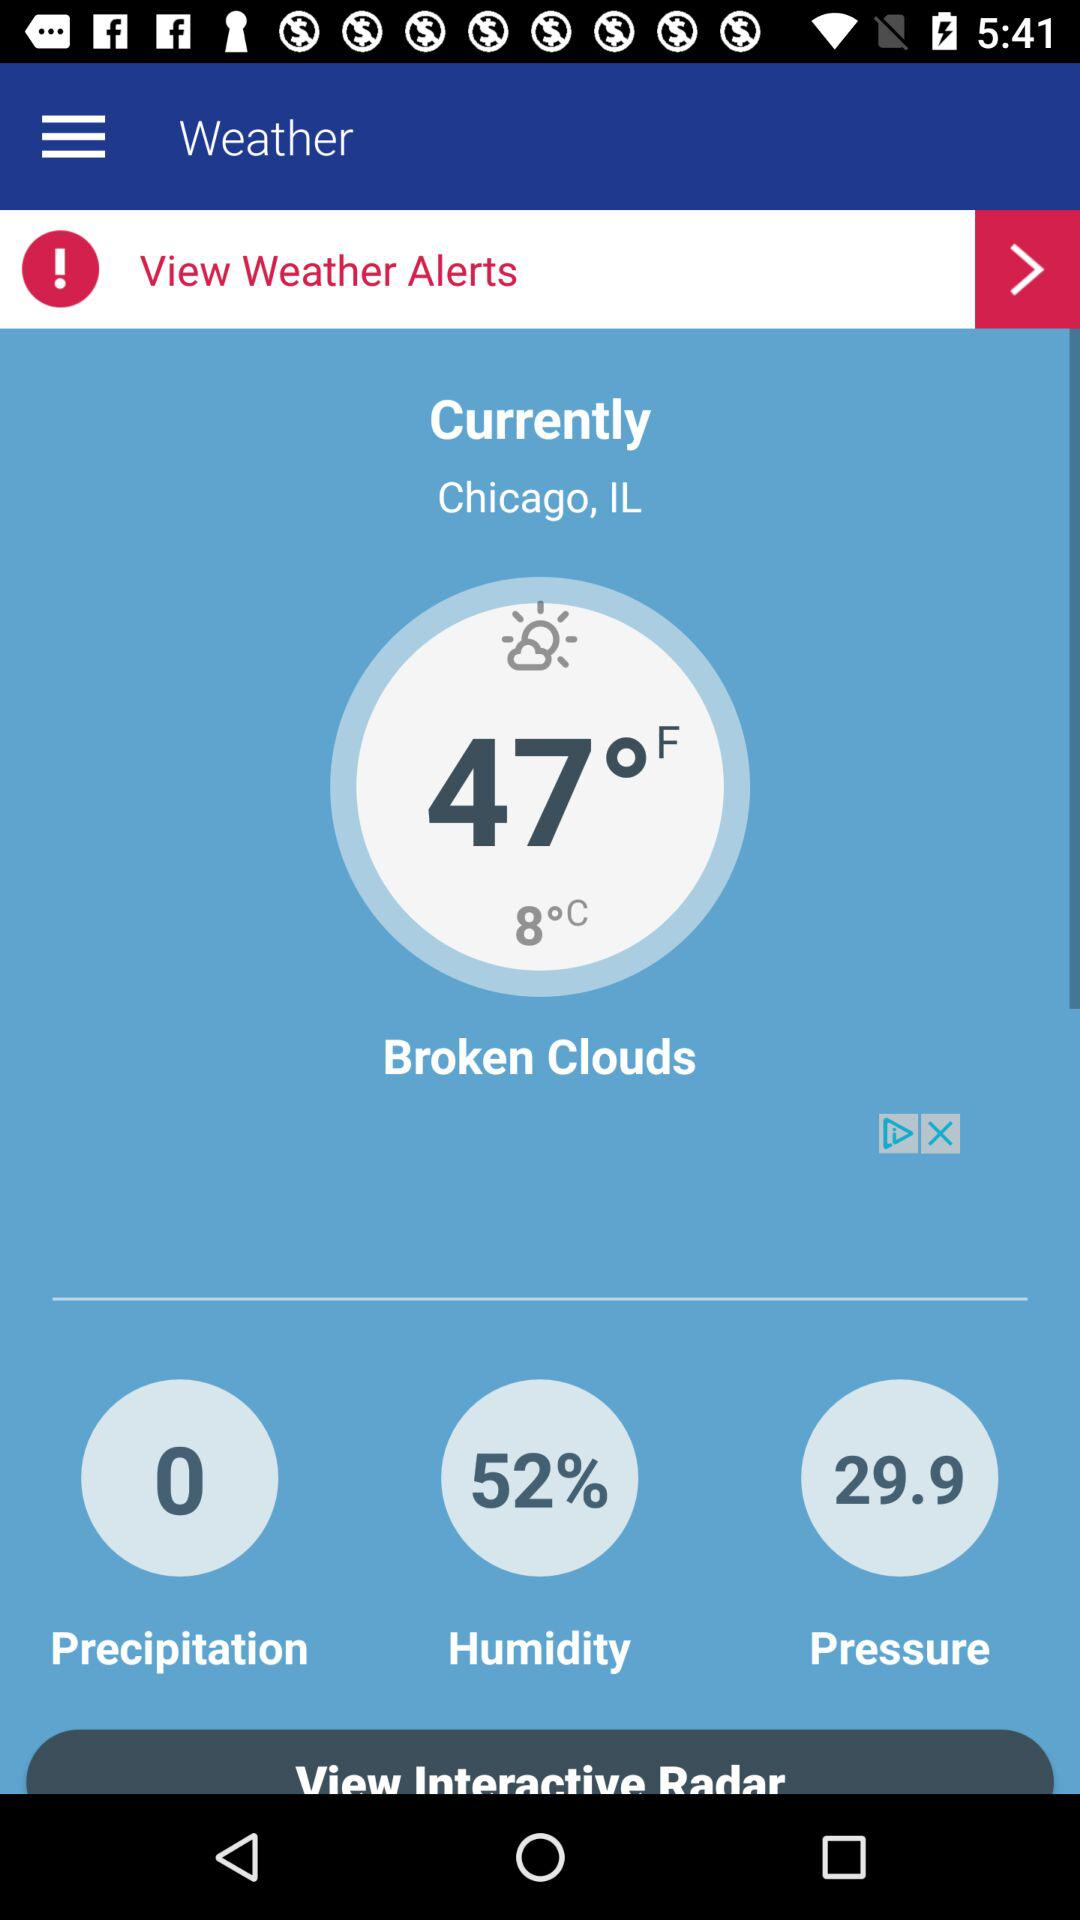How many degrees warmer is it than the freezing point?
Answer the question using a single word or phrase. 39 